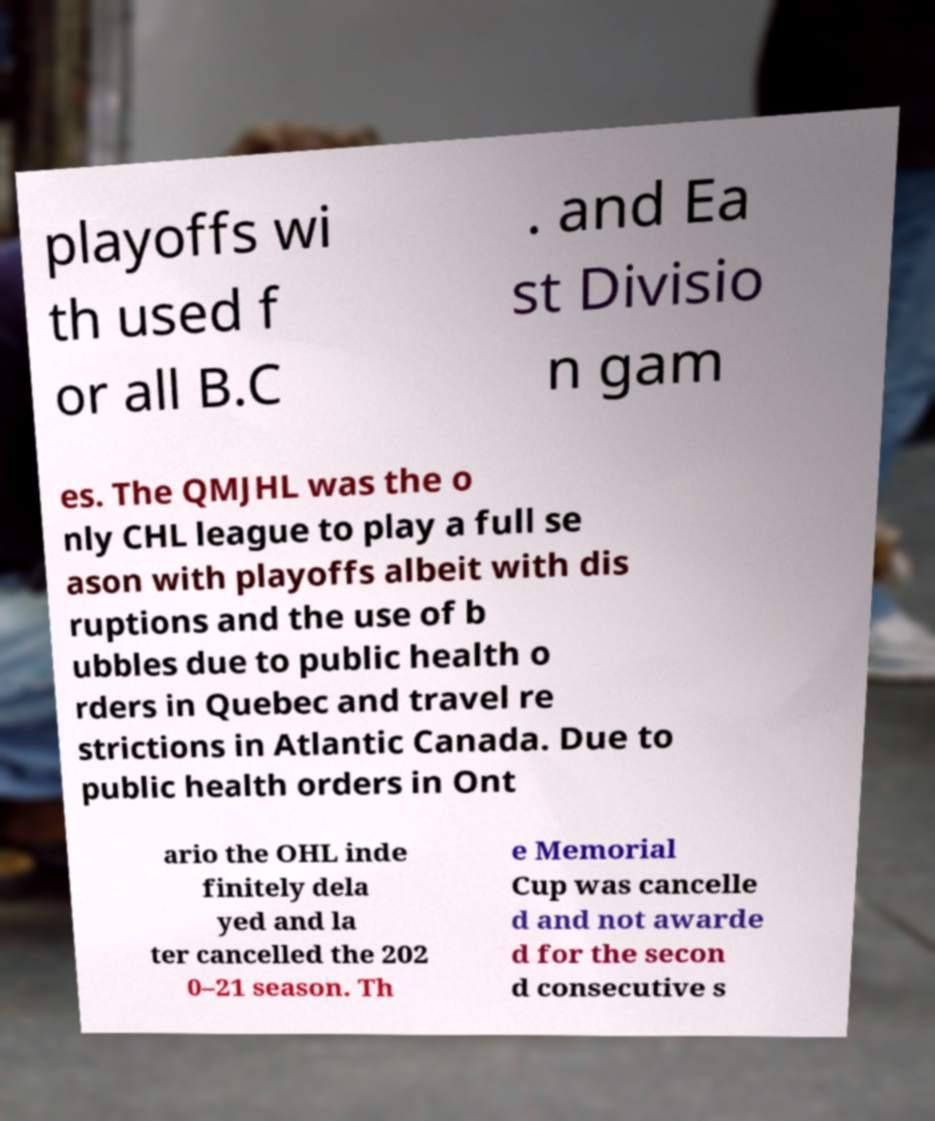Please read and relay the text visible in this image. What does it say? playoffs wi th used f or all B.C . and Ea st Divisio n gam es. The QMJHL was the o nly CHL league to play a full se ason with playoffs albeit with dis ruptions and the use of b ubbles due to public health o rders in Quebec and travel re strictions in Atlantic Canada. Due to public health orders in Ont ario the OHL inde finitely dela yed and la ter cancelled the 202 0–21 season. Th e Memorial Cup was cancelle d and not awarde d for the secon d consecutive s 